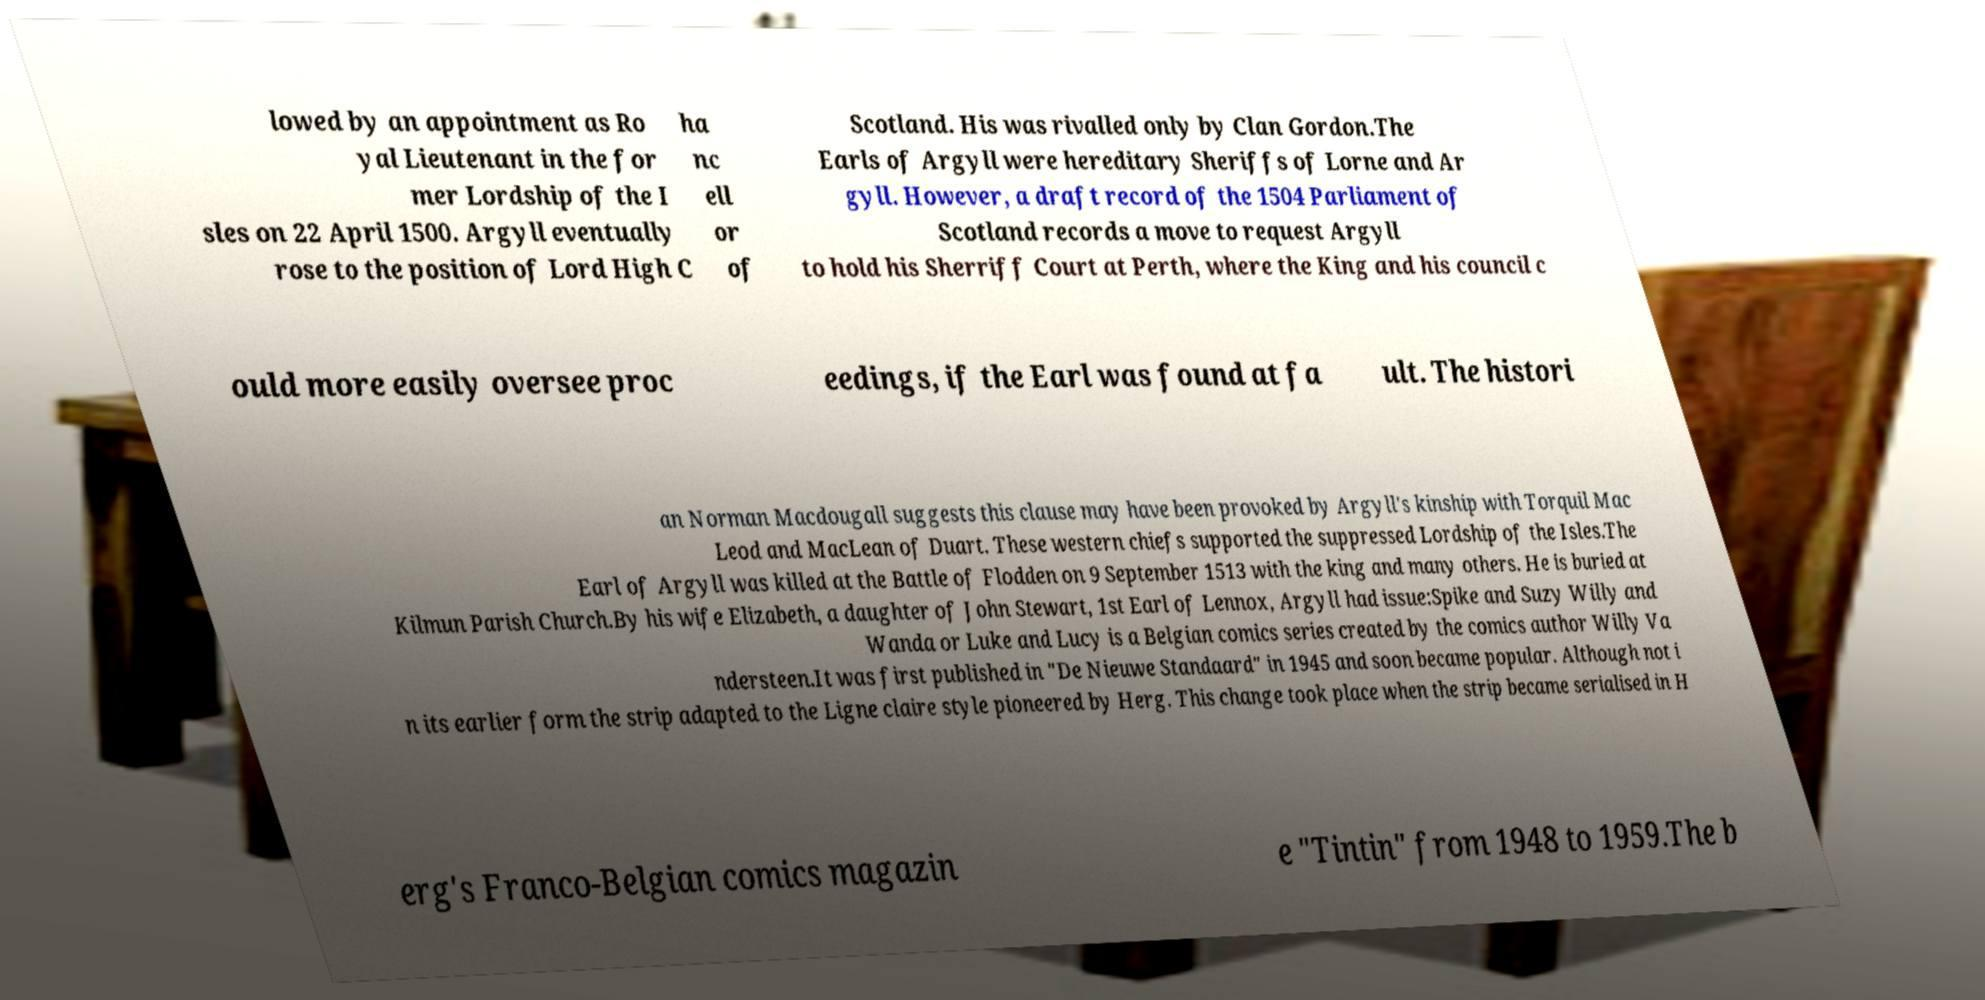What messages or text are displayed in this image? I need them in a readable, typed format. lowed by an appointment as Ro yal Lieutenant in the for mer Lordship of the I sles on 22 April 1500. Argyll eventually rose to the position of Lord High C ha nc ell or of Scotland. His was rivalled only by Clan Gordon.The Earls of Argyll were hereditary Sheriffs of Lorne and Ar gyll. However, a draft record of the 1504 Parliament of Scotland records a move to request Argyll to hold his Sherriff Court at Perth, where the King and his council c ould more easily oversee proc eedings, if the Earl was found at fa ult. The histori an Norman Macdougall suggests this clause may have been provoked by Argyll's kinship with Torquil Mac Leod and MacLean of Duart. These western chiefs supported the suppressed Lordship of the Isles.The Earl of Argyll was killed at the Battle of Flodden on 9 September 1513 with the king and many others. He is buried at Kilmun Parish Church.By his wife Elizabeth, a daughter of John Stewart, 1st Earl of Lennox, Argyll had issue:Spike and Suzy Willy and Wanda or Luke and Lucy is a Belgian comics series created by the comics author Willy Va ndersteen.It was first published in "De Nieuwe Standaard" in 1945 and soon became popular. Although not i n its earlier form the strip adapted to the Ligne claire style pioneered by Herg. This change took place when the strip became serialised in H erg's Franco-Belgian comics magazin e "Tintin" from 1948 to 1959.The b 